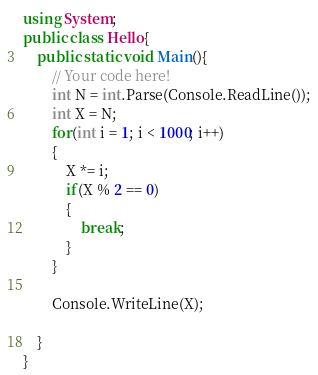Convert code to text. <code><loc_0><loc_0><loc_500><loc_500><_C#_>using System;
public class Hello{
    public static void Main(){
        // Your code here!
        int N = int.Parse(Console.ReadLine());
        int X = N;
        for(int i = 1; i < 1000; i++)
        {
            X *= i;
            if(X % 2 == 0)
            {
                break;
            }
        }
        
        Console.WriteLine(X);
        
    }
}</code> 